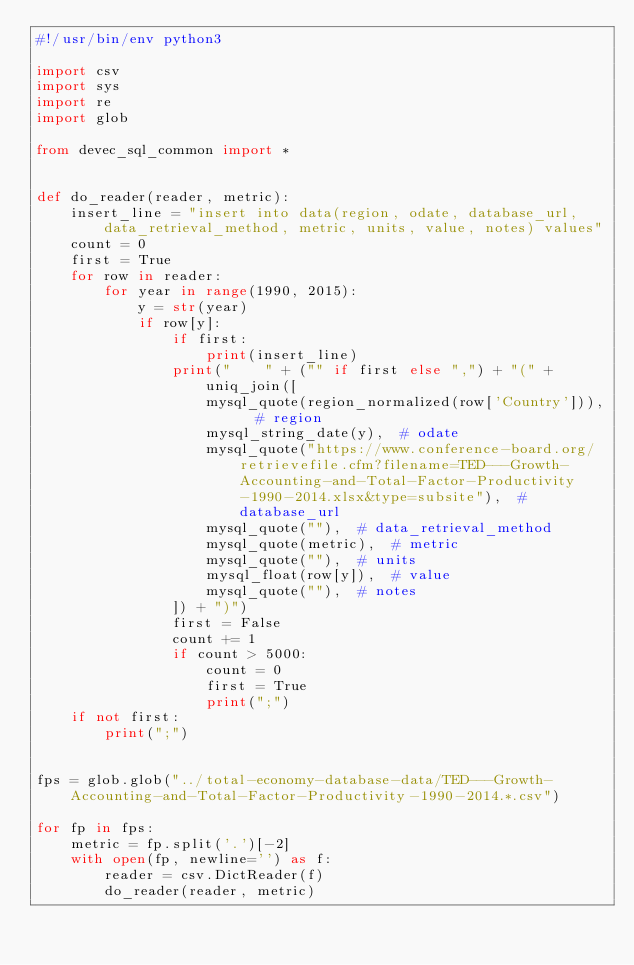<code> <loc_0><loc_0><loc_500><loc_500><_Python_>#!/usr/bin/env python3

import csv
import sys
import re
import glob

from devec_sql_common import *


def do_reader(reader, metric):
    insert_line = "insert into data(region, odate, database_url, data_retrieval_method, metric, units, value, notes) values"
    count = 0
    first = True
    for row in reader:
        for year in range(1990, 2015):
            y = str(year)
            if row[y]:
                if first:
                    print(insert_line)
                print("    " + ("" if first else ",") + "(" + uniq_join([
                    mysql_quote(region_normalized(row['Country'])),  # region
                    mysql_string_date(y),  # odate
                    mysql_quote("https://www.conference-board.org/retrievefile.cfm?filename=TED---Growth-Accounting-and-Total-Factor-Productivity-1990-2014.xlsx&type=subsite"),  # database_url
                    mysql_quote(""),  # data_retrieval_method
                    mysql_quote(metric),  # metric
                    mysql_quote(""),  # units
                    mysql_float(row[y]),  # value
                    mysql_quote(""),  # notes
                ]) + ")")
                first = False
                count += 1
                if count > 5000:
                    count = 0
                    first = True
                    print(";")
    if not first:
        print(";")


fps = glob.glob("../total-economy-database-data/TED---Growth-Accounting-and-Total-Factor-Productivity-1990-2014.*.csv")

for fp in fps:
    metric = fp.split('.')[-2]
    with open(fp, newline='') as f:
        reader = csv.DictReader(f)
        do_reader(reader, metric)
</code> 